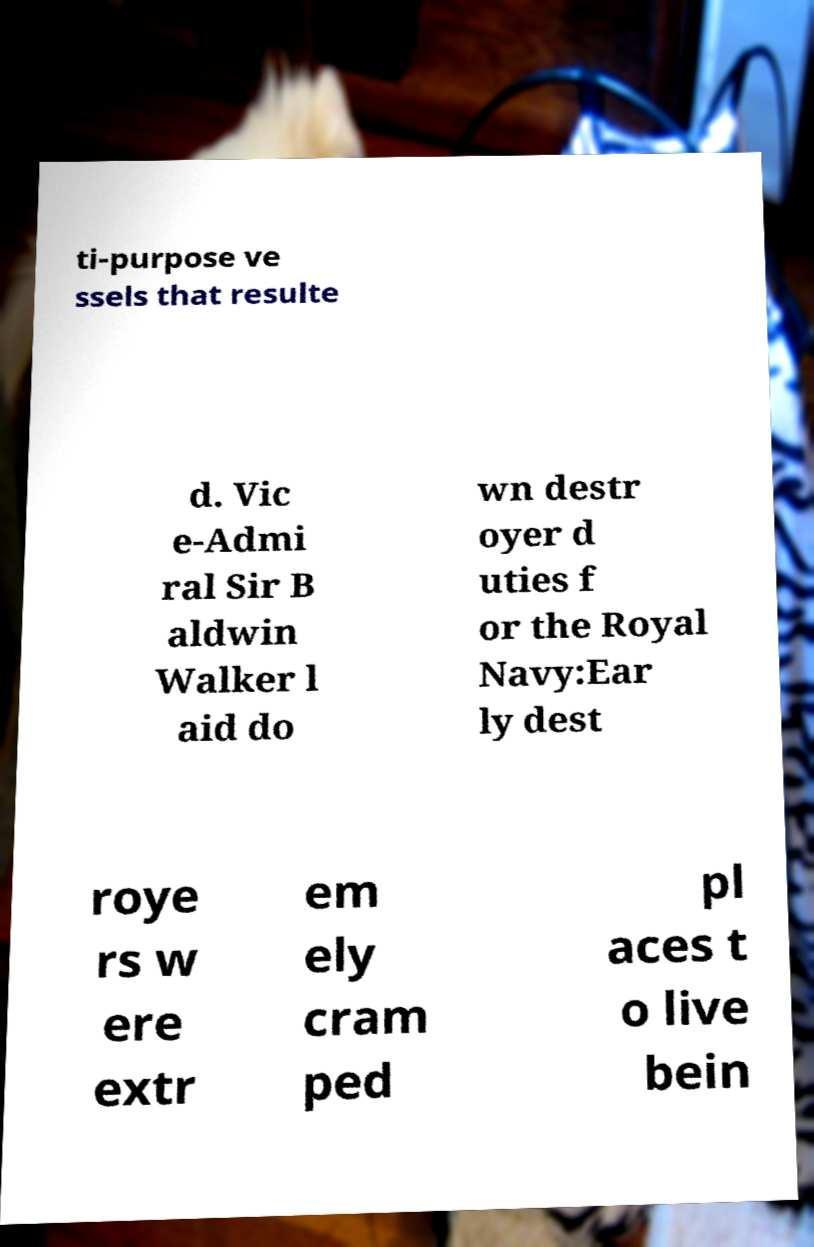I need the written content from this picture converted into text. Can you do that? ti-purpose ve ssels that resulte d. Vic e-Admi ral Sir B aldwin Walker l aid do wn destr oyer d uties f or the Royal Navy:Ear ly dest roye rs w ere extr em ely cram ped pl aces t o live bein 